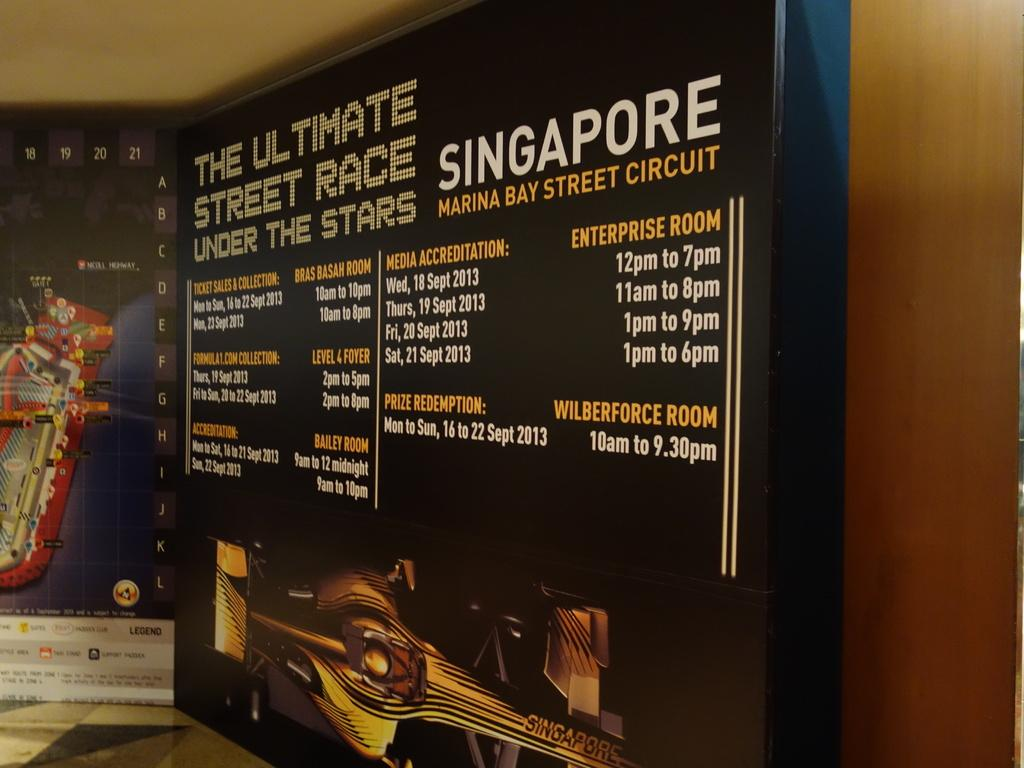<image>
Give a short and clear explanation of the subsequent image. A sign displays an ad for the ultimate street race under the stars. 